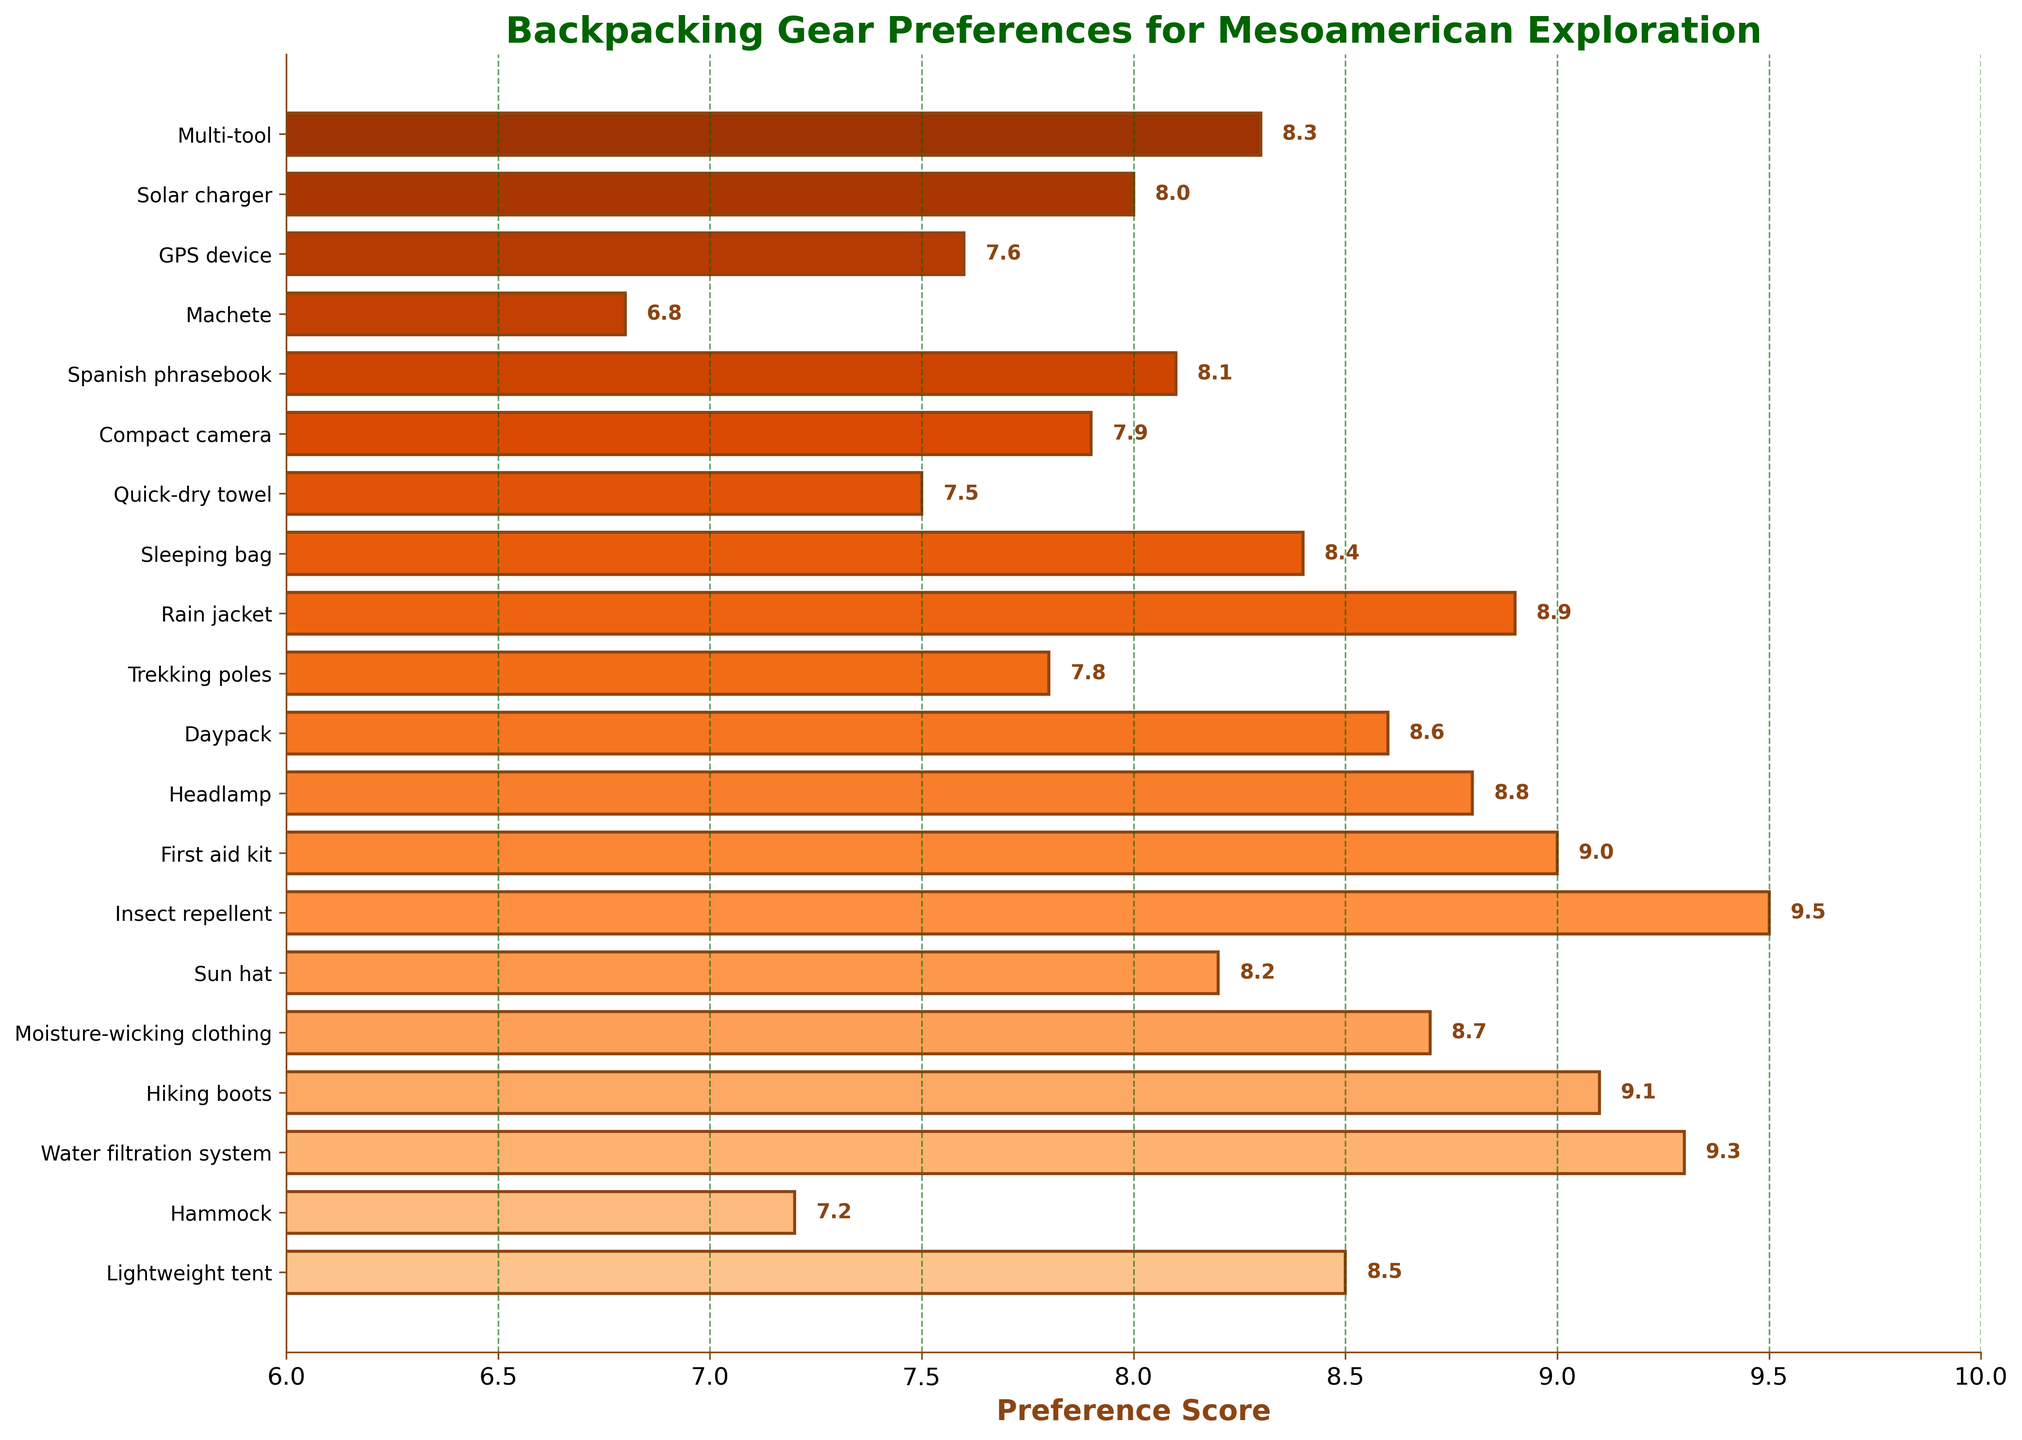What's the highest preference score for backpacking gear? First, observe all the values listed next to each bar in the chart. The highest value among them is 9.5, which corresponds to the item "Insect repellent”.
Answer: 9.5 Which item has the lowest preference score? Look at all the values associated with each bar to find the minimum value. The lowest preference score is 6.8, which belongs to the item "Machete".
Answer: Machete What is the combined preference score of the top three items? Identify the top three items by their scores: Insect repellent (9.5), Water filtration system (9.3), and Hiking boots (9.1). Add these values: 9.5 + 9.3 + 9.1 = 27.9.
Answer: 27.9 Which item has a preference score equal to or greater than 9.0 but less than 9.5? Observe the values on the scale that are between 9.0 and 9.5. The items that meet this condition are “Insect repellent” (9.5), “Water filtration system” (9.3), “Hiking boots” (9.1), and “First aid kit” (9.0). The one that is equal to 9.5 should be excluded, leaving Water filtration system, Hiking boots, and First aid kit.
Answer: Water filtration system, Hiking boots, First aid kit Compare the preference scores for "Hammock" and "Daypack", which one is higher and by how much? Find the preference scores for "Hammock" (7.2) and "Daypack" (8.6). Subtract the lower score from the higher score: 8.6 - 7.2 = 1.4. "Daypack" has a higher score than "Hammock" by 1.4.
Answer: Daypack by 1.4 What is the average preference score of the following items: "Headlamp", "Daypack", "Trekking poles"? Find the individual scores: "Headlamp" (8.8), "Daypack" (8.6), "Trekking poles" (7.8). Calculate the sum: 8.8 + 8.6 + 7.8 = 25.2. Divide the sum by the number of items which is 3: 25.2 / 3 = 8.4.
Answer: 8.4 Which item has the longest bar and why? Identify the item with the tallest bar using the values. The item with the longest bar is "Insect repellent" because it has the highest preference score of 9.5.
Answer: Insect repellent Which items have preference scores within the range of 7.0 to 8.0 inclusive? Look for the bars whose scores fall between 7.0 and 8.0 inclusive. These items are "Hammock" (7.2), "Trekking poles" (7.8), "GPS device" (7.6), and "Quick-dry towel" (7.5).
Answer: Hammock, Trekking poles, GPS device, Quick-dry towel 